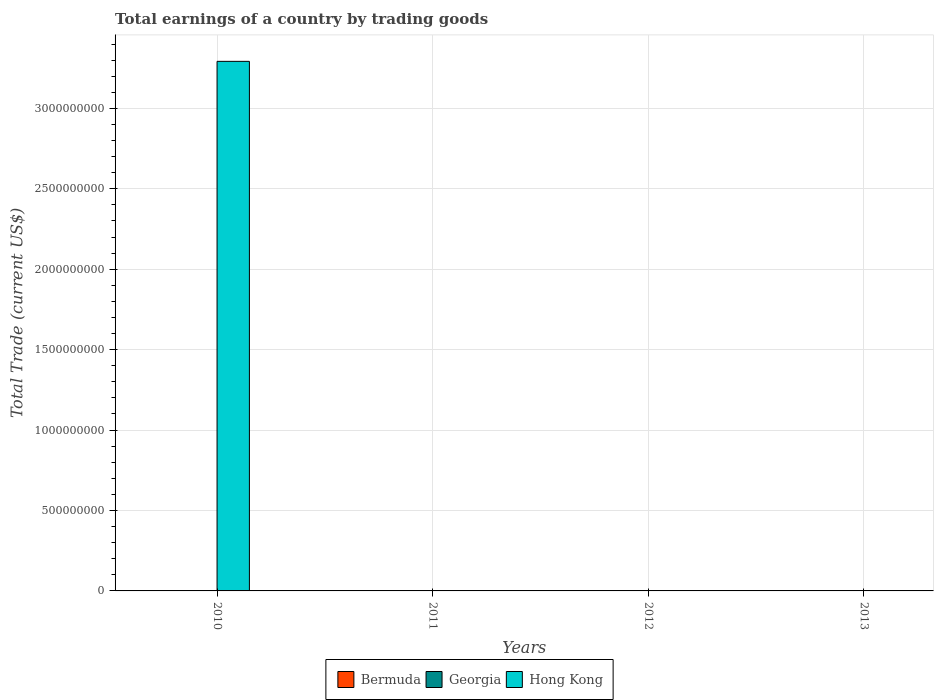Are the number of bars per tick equal to the number of legend labels?
Your answer should be very brief. No. How many bars are there on the 4th tick from the right?
Provide a short and direct response. 1. What is the label of the 3rd group of bars from the left?
Keep it short and to the point. 2012. In how many cases, is the number of bars for a given year not equal to the number of legend labels?
Offer a very short reply. 4. What is the total earnings in Hong Kong in 2012?
Provide a short and direct response. 0. Across all years, what is the maximum total earnings in Hong Kong?
Offer a very short reply. 3.29e+09. Across all years, what is the minimum total earnings in Bermuda?
Give a very brief answer. 0. In which year was the total earnings in Hong Kong maximum?
Offer a very short reply. 2010. What is the total total earnings in Georgia in the graph?
Offer a very short reply. 0. What is the difference between the total earnings in Bermuda in 2010 and the total earnings in Hong Kong in 2013?
Offer a terse response. 0. In how many years, is the total earnings in Bermuda greater than 3000000000 US$?
Provide a short and direct response. 0. What is the difference between the highest and the lowest total earnings in Hong Kong?
Ensure brevity in your answer.  3.29e+09. Is it the case that in every year, the sum of the total earnings in Hong Kong and total earnings in Bermuda is greater than the total earnings in Georgia?
Your answer should be compact. No. Are all the bars in the graph horizontal?
Offer a very short reply. No. How many years are there in the graph?
Offer a terse response. 4. What is the difference between two consecutive major ticks on the Y-axis?
Provide a succinct answer. 5.00e+08. Are the values on the major ticks of Y-axis written in scientific E-notation?
Keep it short and to the point. No. Does the graph contain any zero values?
Offer a terse response. Yes. Does the graph contain grids?
Provide a short and direct response. Yes. Where does the legend appear in the graph?
Offer a terse response. Bottom center. How are the legend labels stacked?
Your answer should be compact. Horizontal. What is the title of the graph?
Your answer should be very brief. Total earnings of a country by trading goods. Does "New Caledonia" appear as one of the legend labels in the graph?
Provide a short and direct response. No. What is the label or title of the X-axis?
Keep it short and to the point. Years. What is the label or title of the Y-axis?
Provide a succinct answer. Total Trade (current US$). What is the Total Trade (current US$) in Bermuda in 2010?
Provide a succinct answer. 0. What is the Total Trade (current US$) of Georgia in 2010?
Your answer should be compact. 0. What is the Total Trade (current US$) of Hong Kong in 2010?
Make the answer very short. 3.29e+09. What is the Total Trade (current US$) in Bermuda in 2011?
Give a very brief answer. 0. What is the Total Trade (current US$) in Georgia in 2011?
Make the answer very short. 0. What is the Total Trade (current US$) of Hong Kong in 2011?
Give a very brief answer. 0. What is the Total Trade (current US$) of Bermuda in 2012?
Make the answer very short. 0. What is the Total Trade (current US$) of Bermuda in 2013?
Your answer should be very brief. 0. What is the Total Trade (current US$) of Hong Kong in 2013?
Your answer should be very brief. 0. Across all years, what is the maximum Total Trade (current US$) of Hong Kong?
Keep it short and to the point. 3.29e+09. Across all years, what is the minimum Total Trade (current US$) of Hong Kong?
Your response must be concise. 0. What is the total Total Trade (current US$) in Bermuda in the graph?
Provide a succinct answer. 0. What is the total Total Trade (current US$) in Hong Kong in the graph?
Provide a succinct answer. 3.29e+09. What is the average Total Trade (current US$) in Bermuda per year?
Offer a very short reply. 0. What is the average Total Trade (current US$) of Hong Kong per year?
Your answer should be compact. 8.23e+08. What is the difference between the highest and the lowest Total Trade (current US$) in Hong Kong?
Offer a terse response. 3.29e+09. 